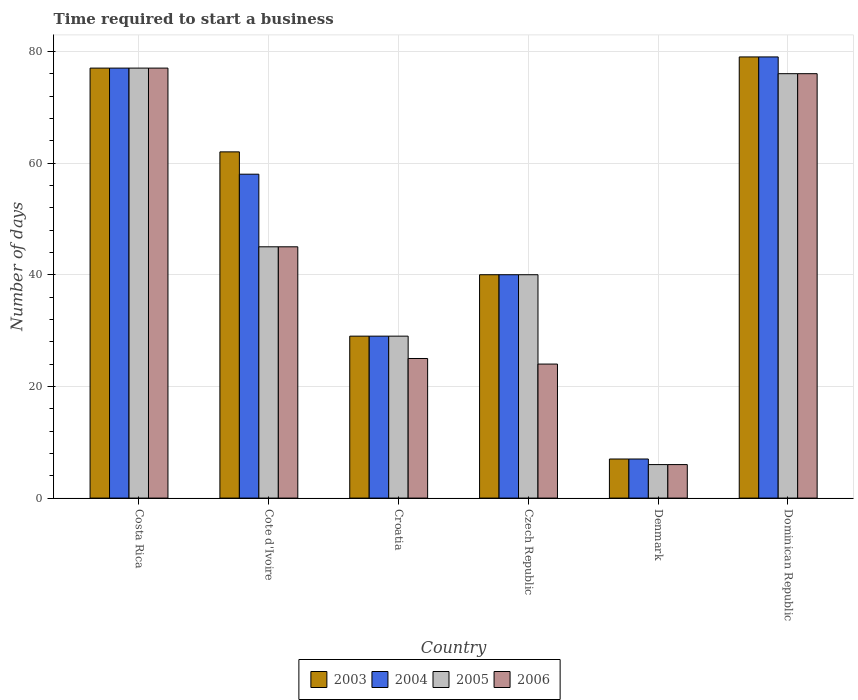How many groups of bars are there?
Your answer should be very brief. 6. Are the number of bars per tick equal to the number of legend labels?
Offer a terse response. Yes. How many bars are there on the 3rd tick from the right?
Your answer should be compact. 4. What is the label of the 3rd group of bars from the left?
Give a very brief answer. Croatia. In how many cases, is the number of bars for a given country not equal to the number of legend labels?
Ensure brevity in your answer.  0. Across all countries, what is the maximum number of days required to start a business in 2004?
Give a very brief answer. 79. In which country was the number of days required to start a business in 2005 maximum?
Your response must be concise. Costa Rica. What is the total number of days required to start a business in 2003 in the graph?
Offer a very short reply. 294. What is the average number of days required to start a business in 2005 per country?
Offer a terse response. 45.5. In how many countries, is the number of days required to start a business in 2004 greater than 4 days?
Your answer should be very brief. 6. What is the ratio of the number of days required to start a business in 2005 in Czech Republic to that in Dominican Republic?
Offer a terse response. 0.53. What is the difference between the highest and the second highest number of days required to start a business in 2005?
Give a very brief answer. -31. What is the difference between the highest and the lowest number of days required to start a business in 2006?
Give a very brief answer. 71. Is it the case that in every country, the sum of the number of days required to start a business in 2006 and number of days required to start a business in 2003 is greater than the number of days required to start a business in 2004?
Your answer should be compact. Yes. How many bars are there?
Provide a succinct answer. 24. How many countries are there in the graph?
Keep it short and to the point. 6. Does the graph contain grids?
Your answer should be very brief. Yes. Where does the legend appear in the graph?
Your answer should be very brief. Bottom center. What is the title of the graph?
Ensure brevity in your answer.  Time required to start a business. What is the label or title of the Y-axis?
Offer a terse response. Number of days. What is the Number of days in 2003 in Costa Rica?
Your answer should be compact. 77. What is the Number of days in 2003 in Cote d'Ivoire?
Keep it short and to the point. 62. What is the Number of days of 2004 in Cote d'Ivoire?
Your answer should be compact. 58. What is the Number of days in 2006 in Cote d'Ivoire?
Provide a succinct answer. 45. What is the Number of days in 2004 in Croatia?
Make the answer very short. 29. What is the Number of days in 2004 in Czech Republic?
Your answer should be very brief. 40. What is the Number of days in 2004 in Denmark?
Your answer should be compact. 7. What is the Number of days in 2005 in Denmark?
Provide a short and direct response. 6. What is the Number of days of 2006 in Denmark?
Your response must be concise. 6. What is the Number of days in 2003 in Dominican Republic?
Keep it short and to the point. 79. What is the Number of days in 2004 in Dominican Republic?
Offer a very short reply. 79. What is the Number of days in 2005 in Dominican Republic?
Keep it short and to the point. 76. Across all countries, what is the maximum Number of days in 2003?
Ensure brevity in your answer.  79. Across all countries, what is the maximum Number of days in 2004?
Give a very brief answer. 79. Across all countries, what is the maximum Number of days of 2006?
Your answer should be compact. 77. Across all countries, what is the minimum Number of days in 2003?
Your response must be concise. 7. Across all countries, what is the minimum Number of days of 2006?
Ensure brevity in your answer.  6. What is the total Number of days in 2003 in the graph?
Keep it short and to the point. 294. What is the total Number of days in 2004 in the graph?
Make the answer very short. 290. What is the total Number of days of 2005 in the graph?
Your answer should be compact. 273. What is the total Number of days of 2006 in the graph?
Your answer should be very brief. 253. What is the difference between the Number of days in 2004 in Costa Rica and that in Cote d'Ivoire?
Your response must be concise. 19. What is the difference between the Number of days in 2005 in Costa Rica and that in Cote d'Ivoire?
Keep it short and to the point. 32. What is the difference between the Number of days of 2006 in Costa Rica and that in Cote d'Ivoire?
Provide a succinct answer. 32. What is the difference between the Number of days in 2003 in Costa Rica and that in Czech Republic?
Offer a very short reply. 37. What is the difference between the Number of days of 2004 in Costa Rica and that in Czech Republic?
Offer a terse response. 37. What is the difference between the Number of days of 2005 in Costa Rica and that in Denmark?
Give a very brief answer. 71. What is the difference between the Number of days of 2006 in Costa Rica and that in Denmark?
Offer a terse response. 71. What is the difference between the Number of days in 2003 in Costa Rica and that in Dominican Republic?
Provide a succinct answer. -2. What is the difference between the Number of days of 2005 in Costa Rica and that in Dominican Republic?
Your response must be concise. 1. What is the difference between the Number of days in 2003 in Cote d'Ivoire and that in Croatia?
Provide a succinct answer. 33. What is the difference between the Number of days in 2004 in Cote d'Ivoire and that in Croatia?
Keep it short and to the point. 29. What is the difference between the Number of days of 2005 in Cote d'Ivoire and that in Croatia?
Your answer should be very brief. 16. What is the difference between the Number of days in 2006 in Cote d'Ivoire and that in Croatia?
Your answer should be very brief. 20. What is the difference between the Number of days of 2003 in Cote d'Ivoire and that in Czech Republic?
Make the answer very short. 22. What is the difference between the Number of days of 2006 in Cote d'Ivoire and that in Czech Republic?
Make the answer very short. 21. What is the difference between the Number of days of 2004 in Cote d'Ivoire and that in Denmark?
Make the answer very short. 51. What is the difference between the Number of days in 2005 in Cote d'Ivoire and that in Denmark?
Give a very brief answer. 39. What is the difference between the Number of days of 2006 in Cote d'Ivoire and that in Denmark?
Provide a short and direct response. 39. What is the difference between the Number of days in 2003 in Cote d'Ivoire and that in Dominican Republic?
Provide a succinct answer. -17. What is the difference between the Number of days of 2005 in Cote d'Ivoire and that in Dominican Republic?
Provide a short and direct response. -31. What is the difference between the Number of days in 2006 in Cote d'Ivoire and that in Dominican Republic?
Your answer should be very brief. -31. What is the difference between the Number of days in 2003 in Croatia and that in Czech Republic?
Offer a very short reply. -11. What is the difference between the Number of days in 2004 in Croatia and that in Czech Republic?
Provide a short and direct response. -11. What is the difference between the Number of days in 2005 in Croatia and that in Czech Republic?
Your answer should be compact. -11. What is the difference between the Number of days in 2003 in Croatia and that in Denmark?
Give a very brief answer. 22. What is the difference between the Number of days in 2006 in Croatia and that in Denmark?
Provide a succinct answer. 19. What is the difference between the Number of days of 2003 in Croatia and that in Dominican Republic?
Your answer should be very brief. -50. What is the difference between the Number of days of 2004 in Croatia and that in Dominican Republic?
Your answer should be very brief. -50. What is the difference between the Number of days in 2005 in Croatia and that in Dominican Republic?
Your answer should be compact. -47. What is the difference between the Number of days in 2006 in Croatia and that in Dominican Republic?
Provide a short and direct response. -51. What is the difference between the Number of days of 2003 in Czech Republic and that in Denmark?
Your answer should be compact. 33. What is the difference between the Number of days in 2004 in Czech Republic and that in Denmark?
Provide a short and direct response. 33. What is the difference between the Number of days of 2006 in Czech Republic and that in Denmark?
Give a very brief answer. 18. What is the difference between the Number of days in 2003 in Czech Republic and that in Dominican Republic?
Offer a terse response. -39. What is the difference between the Number of days of 2004 in Czech Republic and that in Dominican Republic?
Provide a short and direct response. -39. What is the difference between the Number of days in 2005 in Czech Republic and that in Dominican Republic?
Give a very brief answer. -36. What is the difference between the Number of days of 2006 in Czech Republic and that in Dominican Republic?
Provide a short and direct response. -52. What is the difference between the Number of days in 2003 in Denmark and that in Dominican Republic?
Provide a short and direct response. -72. What is the difference between the Number of days in 2004 in Denmark and that in Dominican Republic?
Your answer should be compact. -72. What is the difference between the Number of days in 2005 in Denmark and that in Dominican Republic?
Provide a short and direct response. -70. What is the difference between the Number of days of 2006 in Denmark and that in Dominican Republic?
Make the answer very short. -70. What is the difference between the Number of days of 2003 in Costa Rica and the Number of days of 2004 in Cote d'Ivoire?
Your answer should be compact. 19. What is the difference between the Number of days in 2003 in Costa Rica and the Number of days in 2006 in Cote d'Ivoire?
Provide a short and direct response. 32. What is the difference between the Number of days in 2004 in Costa Rica and the Number of days in 2005 in Cote d'Ivoire?
Make the answer very short. 32. What is the difference between the Number of days in 2005 in Costa Rica and the Number of days in 2006 in Cote d'Ivoire?
Your answer should be very brief. 32. What is the difference between the Number of days in 2003 in Costa Rica and the Number of days in 2004 in Croatia?
Give a very brief answer. 48. What is the difference between the Number of days in 2003 in Costa Rica and the Number of days in 2005 in Croatia?
Offer a very short reply. 48. What is the difference between the Number of days in 2003 in Costa Rica and the Number of days in 2006 in Croatia?
Give a very brief answer. 52. What is the difference between the Number of days in 2003 in Costa Rica and the Number of days in 2004 in Czech Republic?
Make the answer very short. 37. What is the difference between the Number of days of 2003 in Costa Rica and the Number of days of 2005 in Czech Republic?
Provide a succinct answer. 37. What is the difference between the Number of days of 2003 in Costa Rica and the Number of days of 2006 in Czech Republic?
Offer a terse response. 53. What is the difference between the Number of days in 2005 in Costa Rica and the Number of days in 2006 in Czech Republic?
Provide a succinct answer. 53. What is the difference between the Number of days of 2003 in Costa Rica and the Number of days of 2004 in Denmark?
Keep it short and to the point. 70. What is the difference between the Number of days in 2004 in Costa Rica and the Number of days in 2006 in Denmark?
Your answer should be compact. 71. What is the difference between the Number of days of 2003 in Costa Rica and the Number of days of 2006 in Dominican Republic?
Your response must be concise. 1. What is the difference between the Number of days in 2005 in Costa Rica and the Number of days in 2006 in Dominican Republic?
Keep it short and to the point. 1. What is the difference between the Number of days of 2003 in Cote d'Ivoire and the Number of days of 2005 in Croatia?
Provide a short and direct response. 33. What is the difference between the Number of days of 2003 in Cote d'Ivoire and the Number of days of 2006 in Croatia?
Give a very brief answer. 37. What is the difference between the Number of days in 2004 in Cote d'Ivoire and the Number of days in 2005 in Croatia?
Provide a succinct answer. 29. What is the difference between the Number of days in 2005 in Cote d'Ivoire and the Number of days in 2006 in Croatia?
Keep it short and to the point. 20. What is the difference between the Number of days of 2003 in Cote d'Ivoire and the Number of days of 2005 in Czech Republic?
Your response must be concise. 22. What is the difference between the Number of days in 2003 in Cote d'Ivoire and the Number of days in 2006 in Czech Republic?
Offer a terse response. 38. What is the difference between the Number of days of 2004 in Cote d'Ivoire and the Number of days of 2005 in Czech Republic?
Ensure brevity in your answer.  18. What is the difference between the Number of days of 2004 in Cote d'Ivoire and the Number of days of 2006 in Czech Republic?
Offer a terse response. 34. What is the difference between the Number of days of 2005 in Cote d'Ivoire and the Number of days of 2006 in Czech Republic?
Offer a terse response. 21. What is the difference between the Number of days in 2003 in Cote d'Ivoire and the Number of days in 2005 in Denmark?
Provide a succinct answer. 56. What is the difference between the Number of days of 2004 in Cote d'Ivoire and the Number of days of 2005 in Denmark?
Make the answer very short. 52. What is the difference between the Number of days in 2003 in Cote d'Ivoire and the Number of days in 2004 in Dominican Republic?
Provide a succinct answer. -17. What is the difference between the Number of days in 2003 in Cote d'Ivoire and the Number of days in 2005 in Dominican Republic?
Provide a short and direct response. -14. What is the difference between the Number of days in 2003 in Cote d'Ivoire and the Number of days in 2006 in Dominican Republic?
Provide a succinct answer. -14. What is the difference between the Number of days in 2004 in Cote d'Ivoire and the Number of days in 2006 in Dominican Republic?
Your answer should be very brief. -18. What is the difference between the Number of days of 2005 in Cote d'Ivoire and the Number of days of 2006 in Dominican Republic?
Provide a short and direct response. -31. What is the difference between the Number of days of 2003 in Croatia and the Number of days of 2004 in Czech Republic?
Your answer should be very brief. -11. What is the difference between the Number of days of 2004 in Croatia and the Number of days of 2005 in Czech Republic?
Your answer should be compact. -11. What is the difference between the Number of days of 2004 in Croatia and the Number of days of 2006 in Czech Republic?
Keep it short and to the point. 5. What is the difference between the Number of days in 2003 in Croatia and the Number of days in 2004 in Denmark?
Your answer should be compact. 22. What is the difference between the Number of days in 2003 in Croatia and the Number of days in 2006 in Denmark?
Give a very brief answer. 23. What is the difference between the Number of days in 2003 in Croatia and the Number of days in 2005 in Dominican Republic?
Your answer should be very brief. -47. What is the difference between the Number of days in 2003 in Croatia and the Number of days in 2006 in Dominican Republic?
Make the answer very short. -47. What is the difference between the Number of days of 2004 in Croatia and the Number of days of 2005 in Dominican Republic?
Give a very brief answer. -47. What is the difference between the Number of days in 2004 in Croatia and the Number of days in 2006 in Dominican Republic?
Provide a short and direct response. -47. What is the difference between the Number of days of 2005 in Croatia and the Number of days of 2006 in Dominican Republic?
Provide a succinct answer. -47. What is the difference between the Number of days in 2003 in Czech Republic and the Number of days in 2004 in Denmark?
Give a very brief answer. 33. What is the difference between the Number of days of 2003 in Czech Republic and the Number of days of 2005 in Denmark?
Your answer should be compact. 34. What is the difference between the Number of days in 2004 in Czech Republic and the Number of days in 2005 in Denmark?
Provide a succinct answer. 34. What is the difference between the Number of days of 2005 in Czech Republic and the Number of days of 2006 in Denmark?
Provide a short and direct response. 34. What is the difference between the Number of days in 2003 in Czech Republic and the Number of days in 2004 in Dominican Republic?
Your answer should be very brief. -39. What is the difference between the Number of days in 2003 in Czech Republic and the Number of days in 2005 in Dominican Republic?
Your answer should be very brief. -36. What is the difference between the Number of days in 2003 in Czech Republic and the Number of days in 2006 in Dominican Republic?
Your answer should be compact. -36. What is the difference between the Number of days of 2004 in Czech Republic and the Number of days of 2005 in Dominican Republic?
Your answer should be compact. -36. What is the difference between the Number of days of 2004 in Czech Republic and the Number of days of 2006 in Dominican Republic?
Provide a succinct answer. -36. What is the difference between the Number of days of 2005 in Czech Republic and the Number of days of 2006 in Dominican Republic?
Make the answer very short. -36. What is the difference between the Number of days of 2003 in Denmark and the Number of days of 2004 in Dominican Republic?
Make the answer very short. -72. What is the difference between the Number of days of 2003 in Denmark and the Number of days of 2005 in Dominican Republic?
Give a very brief answer. -69. What is the difference between the Number of days in 2003 in Denmark and the Number of days in 2006 in Dominican Republic?
Ensure brevity in your answer.  -69. What is the difference between the Number of days in 2004 in Denmark and the Number of days in 2005 in Dominican Republic?
Make the answer very short. -69. What is the difference between the Number of days of 2004 in Denmark and the Number of days of 2006 in Dominican Republic?
Provide a succinct answer. -69. What is the difference between the Number of days of 2005 in Denmark and the Number of days of 2006 in Dominican Republic?
Ensure brevity in your answer.  -70. What is the average Number of days of 2003 per country?
Provide a succinct answer. 49. What is the average Number of days in 2004 per country?
Provide a succinct answer. 48.33. What is the average Number of days of 2005 per country?
Keep it short and to the point. 45.5. What is the average Number of days in 2006 per country?
Keep it short and to the point. 42.17. What is the difference between the Number of days in 2003 and Number of days in 2005 in Costa Rica?
Your response must be concise. 0. What is the difference between the Number of days of 2003 and Number of days of 2006 in Costa Rica?
Keep it short and to the point. 0. What is the difference between the Number of days of 2004 and Number of days of 2005 in Cote d'Ivoire?
Your response must be concise. 13. What is the difference between the Number of days of 2003 and Number of days of 2006 in Croatia?
Offer a terse response. 4. What is the difference between the Number of days of 2003 and Number of days of 2004 in Czech Republic?
Provide a succinct answer. 0. What is the difference between the Number of days of 2003 and Number of days of 2005 in Czech Republic?
Your response must be concise. 0. What is the difference between the Number of days in 2003 and Number of days in 2006 in Czech Republic?
Your answer should be very brief. 16. What is the difference between the Number of days in 2003 and Number of days in 2004 in Denmark?
Ensure brevity in your answer.  0. What is the difference between the Number of days in 2003 and Number of days in 2005 in Denmark?
Provide a succinct answer. 1. What is the difference between the Number of days in 2003 and Number of days in 2006 in Denmark?
Make the answer very short. 1. What is the difference between the Number of days in 2004 and Number of days in 2006 in Denmark?
Your answer should be compact. 1. What is the difference between the Number of days in 2005 and Number of days in 2006 in Denmark?
Give a very brief answer. 0. What is the ratio of the Number of days of 2003 in Costa Rica to that in Cote d'Ivoire?
Offer a very short reply. 1.24. What is the ratio of the Number of days in 2004 in Costa Rica to that in Cote d'Ivoire?
Provide a succinct answer. 1.33. What is the ratio of the Number of days of 2005 in Costa Rica to that in Cote d'Ivoire?
Your answer should be very brief. 1.71. What is the ratio of the Number of days in 2006 in Costa Rica to that in Cote d'Ivoire?
Your answer should be compact. 1.71. What is the ratio of the Number of days in 2003 in Costa Rica to that in Croatia?
Offer a terse response. 2.66. What is the ratio of the Number of days of 2004 in Costa Rica to that in Croatia?
Your response must be concise. 2.66. What is the ratio of the Number of days in 2005 in Costa Rica to that in Croatia?
Offer a very short reply. 2.66. What is the ratio of the Number of days in 2006 in Costa Rica to that in Croatia?
Your response must be concise. 3.08. What is the ratio of the Number of days of 2003 in Costa Rica to that in Czech Republic?
Ensure brevity in your answer.  1.93. What is the ratio of the Number of days in 2004 in Costa Rica to that in Czech Republic?
Offer a very short reply. 1.93. What is the ratio of the Number of days of 2005 in Costa Rica to that in Czech Republic?
Provide a short and direct response. 1.93. What is the ratio of the Number of days of 2006 in Costa Rica to that in Czech Republic?
Offer a terse response. 3.21. What is the ratio of the Number of days in 2003 in Costa Rica to that in Denmark?
Provide a succinct answer. 11. What is the ratio of the Number of days in 2004 in Costa Rica to that in Denmark?
Ensure brevity in your answer.  11. What is the ratio of the Number of days of 2005 in Costa Rica to that in Denmark?
Provide a short and direct response. 12.83. What is the ratio of the Number of days of 2006 in Costa Rica to that in Denmark?
Your answer should be very brief. 12.83. What is the ratio of the Number of days in 2003 in Costa Rica to that in Dominican Republic?
Keep it short and to the point. 0.97. What is the ratio of the Number of days in 2004 in Costa Rica to that in Dominican Republic?
Your answer should be very brief. 0.97. What is the ratio of the Number of days of 2005 in Costa Rica to that in Dominican Republic?
Make the answer very short. 1.01. What is the ratio of the Number of days in 2006 in Costa Rica to that in Dominican Republic?
Make the answer very short. 1.01. What is the ratio of the Number of days of 2003 in Cote d'Ivoire to that in Croatia?
Your answer should be compact. 2.14. What is the ratio of the Number of days in 2004 in Cote d'Ivoire to that in Croatia?
Offer a very short reply. 2. What is the ratio of the Number of days in 2005 in Cote d'Ivoire to that in Croatia?
Give a very brief answer. 1.55. What is the ratio of the Number of days of 2006 in Cote d'Ivoire to that in Croatia?
Your response must be concise. 1.8. What is the ratio of the Number of days in 2003 in Cote d'Ivoire to that in Czech Republic?
Offer a terse response. 1.55. What is the ratio of the Number of days of 2004 in Cote d'Ivoire to that in Czech Republic?
Provide a short and direct response. 1.45. What is the ratio of the Number of days in 2005 in Cote d'Ivoire to that in Czech Republic?
Your response must be concise. 1.12. What is the ratio of the Number of days in 2006 in Cote d'Ivoire to that in Czech Republic?
Offer a terse response. 1.88. What is the ratio of the Number of days in 2003 in Cote d'Ivoire to that in Denmark?
Offer a terse response. 8.86. What is the ratio of the Number of days in 2004 in Cote d'Ivoire to that in Denmark?
Your answer should be compact. 8.29. What is the ratio of the Number of days of 2005 in Cote d'Ivoire to that in Denmark?
Your response must be concise. 7.5. What is the ratio of the Number of days in 2006 in Cote d'Ivoire to that in Denmark?
Your answer should be compact. 7.5. What is the ratio of the Number of days in 2003 in Cote d'Ivoire to that in Dominican Republic?
Make the answer very short. 0.78. What is the ratio of the Number of days in 2004 in Cote d'Ivoire to that in Dominican Republic?
Give a very brief answer. 0.73. What is the ratio of the Number of days of 2005 in Cote d'Ivoire to that in Dominican Republic?
Keep it short and to the point. 0.59. What is the ratio of the Number of days of 2006 in Cote d'Ivoire to that in Dominican Republic?
Provide a short and direct response. 0.59. What is the ratio of the Number of days of 2003 in Croatia to that in Czech Republic?
Your answer should be very brief. 0.72. What is the ratio of the Number of days of 2004 in Croatia to that in Czech Republic?
Your response must be concise. 0.72. What is the ratio of the Number of days of 2005 in Croatia to that in Czech Republic?
Offer a terse response. 0.72. What is the ratio of the Number of days of 2006 in Croatia to that in Czech Republic?
Your response must be concise. 1.04. What is the ratio of the Number of days in 2003 in Croatia to that in Denmark?
Your answer should be compact. 4.14. What is the ratio of the Number of days of 2004 in Croatia to that in Denmark?
Your answer should be very brief. 4.14. What is the ratio of the Number of days in 2005 in Croatia to that in Denmark?
Your response must be concise. 4.83. What is the ratio of the Number of days in 2006 in Croatia to that in Denmark?
Your answer should be very brief. 4.17. What is the ratio of the Number of days in 2003 in Croatia to that in Dominican Republic?
Provide a short and direct response. 0.37. What is the ratio of the Number of days of 2004 in Croatia to that in Dominican Republic?
Your answer should be very brief. 0.37. What is the ratio of the Number of days in 2005 in Croatia to that in Dominican Republic?
Provide a succinct answer. 0.38. What is the ratio of the Number of days of 2006 in Croatia to that in Dominican Republic?
Keep it short and to the point. 0.33. What is the ratio of the Number of days of 2003 in Czech Republic to that in Denmark?
Make the answer very short. 5.71. What is the ratio of the Number of days in 2004 in Czech Republic to that in Denmark?
Offer a very short reply. 5.71. What is the ratio of the Number of days in 2003 in Czech Republic to that in Dominican Republic?
Offer a very short reply. 0.51. What is the ratio of the Number of days in 2004 in Czech Republic to that in Dominican Republic?
Keep it short and to the point. 0.51. What is the ratio of the Number of days in 2005 in Czech Republic to that in Dominican Republic?
Give a very brief answer. 0.53. What is the ratio of the Number of days of 2006 in Czech Republic to that in Dominican Republic?
Provide a succinct answer. 0.32. What is the ratio of the Number of days of 2003 in Denmark to that in Dominican Republic?
Your answer should be very brief. 0.09. What is the ratio of the Number of days of 2004 in Denmark to that in Dominican Republic?
Ensure brevity in your answer.  0.09. What is the ratio of the Number of days in 2005 in Denmark to that in Dominican Republic?
Your answer should be compact. 0.08. What is the ratio of the Number of days in 2006 in Denmark to that in Dominican Republic?
Provide a succinct answer. 0.08. What is the difference between the highest and the second highest Number of days in 2005?
Your answer should be very brief. 1. What is the difference between the highest and the second highest Number of days in 2006?
Your answer should be very brief. 1. What is the difference between the highest and the lowest Number of days in 2006?
Give a very brief answer. 71. 